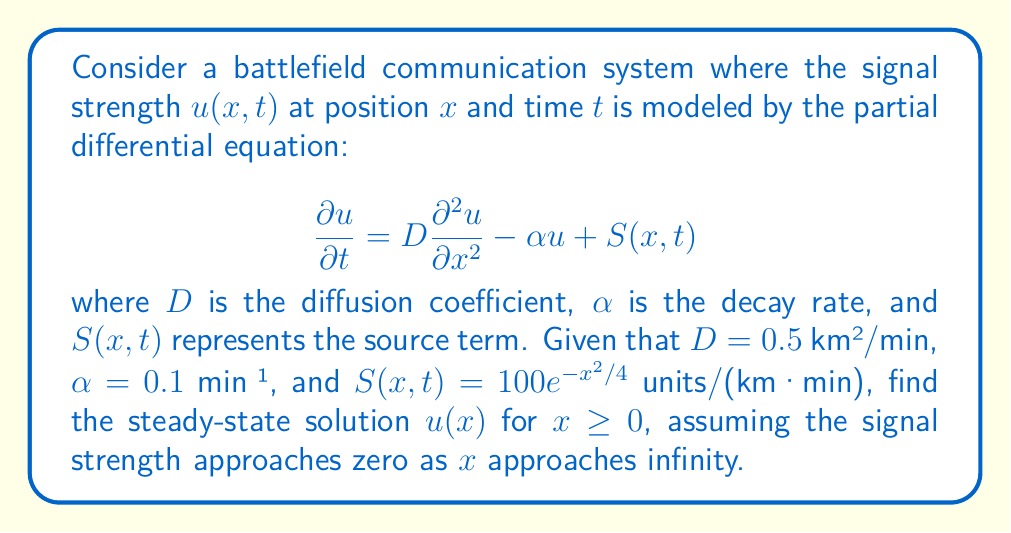Teach me how to tackle this problem. To solve this problem, we'll follow these steps:

1) For the steady-state solution, $\frac{\partial u}{\partial t} = 0$. This reduces our PDE to an ODE:

   $$0 = D\frac{d^2u}{dx^2} - \alpha u + S(x)$$

2) Substituting the given values:

   $$0 = 0.5\frac{d^2u}{dx^2} - 0.1u + 100e^{-x^2/4}$$

3) Rearranging:

   $$\frac{d^2u}{dx^2} - 0.2u = -200e^{-x^2/4}$$

4) This is an inhomogeneous second-order ODE. The general solution will be the sum of the homogeneous solution and a particular solution.

5) For the homogeneous part $\frac{d^2u}{dx^2} - 0.2u = 0$, the characteristic equation is $r^2 - 0.2 = 0$, giving $r = \pm\sqrt{0.2}$.

6) The homogeneous solution is thus:

   $$u_h(x) = Ae^{\sqrt{0.2}x} + Be^{-\sqrt{0.2}x}$$

7) For the particular solution, we can try $u_p(x) = Ce^{-x^2/4}$. Substituting this into the ODE:

   $$C(\frac{x^2}{8} - 0.5)e^{-x^2/4} - 0.2Ce^{-x^2/4} = -200e^{-x^2/4}$$

8) Equating coefficients:

   $$C(\frac{x^2}{8} - 0.5 - 0.2) = -200$$

   $$C = \frac{200}{0.7 - \frac{x^2}{8}}$$

9) As this should be true for all $x$, we can conclude $C = 200/0.7 \approx 285.71$.

10) The general solution is thus:

    $$u(x) = Ae^{\sqrt{0.2}x} + Be^{-\sqrt{0.2}x} + 285.71e^{-x^2/4}$$

11) Given that $u(x) \to 0$ as $x \to \infty$, we must have $A = 0$.

12) Our final solution is:

    $$u(x) = Be^{-\sqrt{0.2}x} + 285.71e^{-x^2/4}$$

The constant $B$ would be determined by a boundary condition at $x = 0$, which is not provided in this problem.
Answer: The steady-state solution for $x \geq 0$ is:

$$u(x) = Be^{-\sqrt{0.2}x} + 285.71e^{-x^2/4}$$

where $B$ is a constant determined by the boundary condition at $x = 0$. 